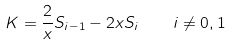Convert formula to latex. <formula><loc_0><loc_0><loc_500><loc_500>K = \frac { 2 } { x } S _ { i - 1 } - 2 x S _ { i } \quad i \neq 0 , 1</formula> 